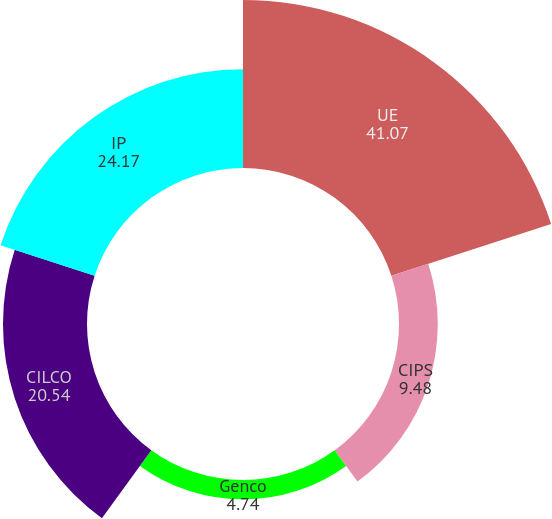<chart> <loc_0><loc_0><loc_500><loc_500><pie_chart><fcel>UE<fcel>CIPS<fcel>Genco<fcel>CILCO<fcel>IP<nl><fcel>41.07%<fcel>9.48%<fcel>4.74%<fcel>20.54%<fcel>24.17%<nl></chart> 